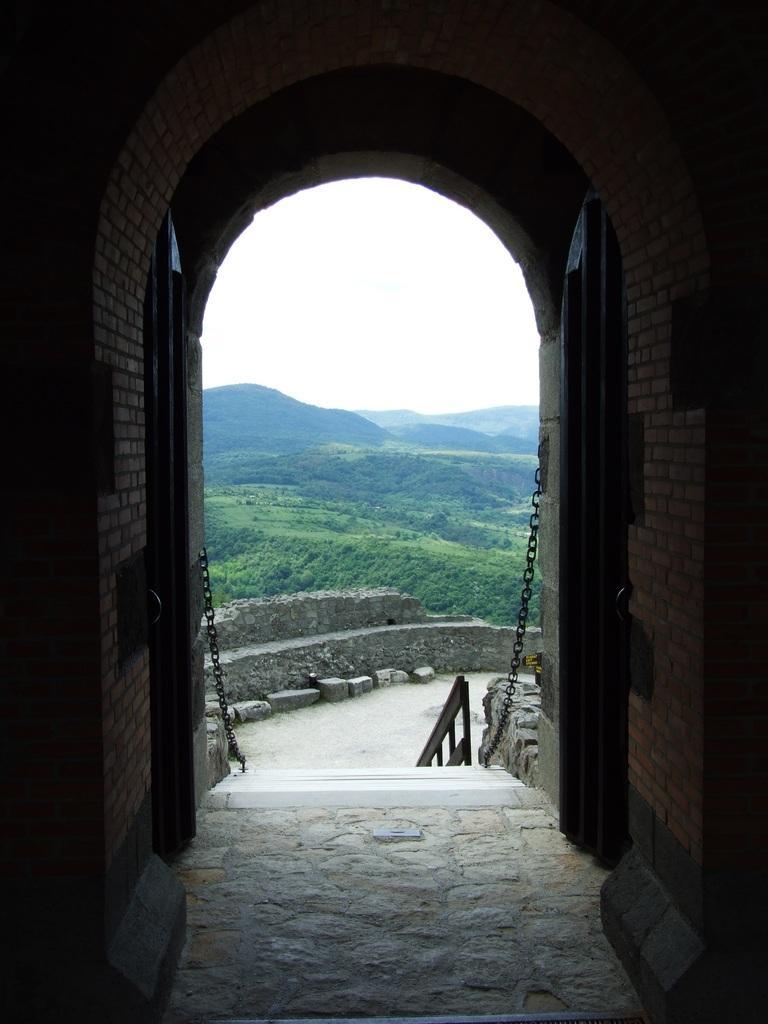Describe this image in one or two sentences. In this image I can see the building. There is a chain in-front of the building. In the background I can see the rocks, mountains and the white sky. 